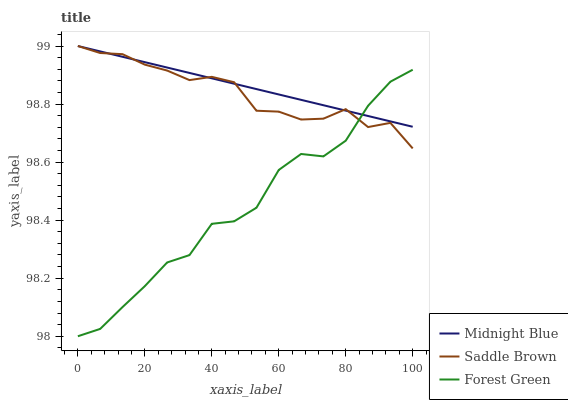Does Forest Green have the minimum area under the curve?
Answer yes or no. Yes. Does Midnight Blue have the maximum area under the curve?
Answer yes or no. Yes. Does Saddle Brown have the minimum area under the curve?
Answer yes or no. No. Does Saddle Brown have the maximum area under the curve?
Answer yes or no. No. Is Midnight Blue the smoothest?
Answer yes or no. Yes. Is Forest Green the roughest?
Answer yes or no. Yes. Is Saddle Brown the smoothest?
Answer yes or no. No. Is Saddle Brown the roughest?
Answer yes or no. No. Does Forest Green have the lowest value?
Answer yes or no. Yes. Does Saddle Brown have the lowest value?
Answer yes or no. No. Does Saddle Brown have the highest value?
Answer yes or no. Yes. Does Midnight Blue intersect Saddle Brown?
Answer yes or no. Yes. Is Midnight Blue less than Saddle Brown?
Answer yes or no. No. Is Midnight Blue greater than Saddle Brown?
Answer yes or no. No. 